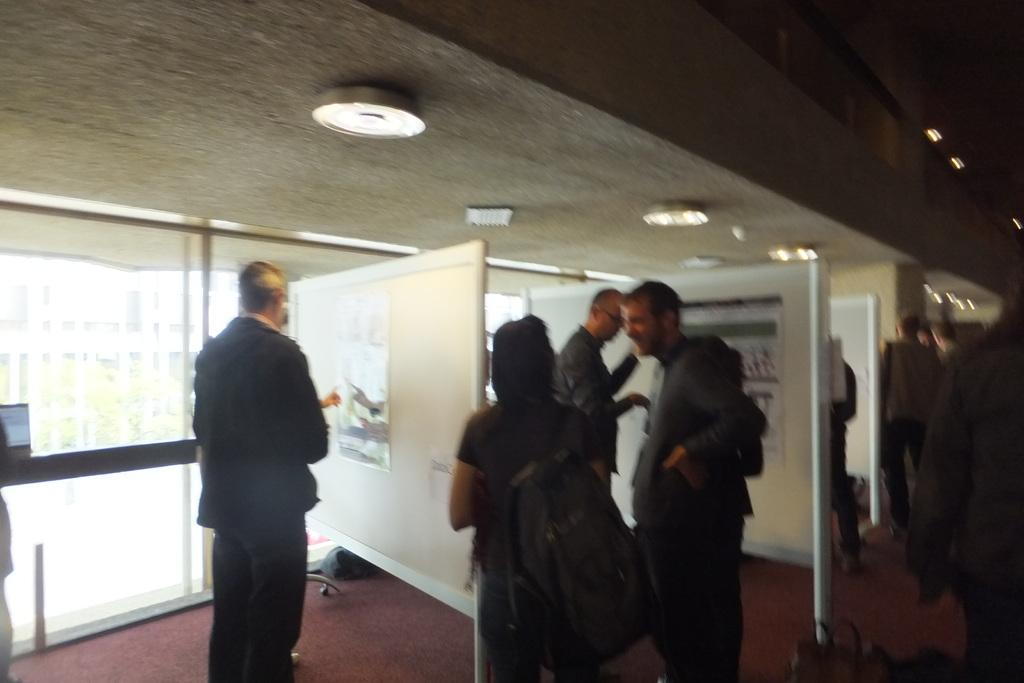What is the main subject of the image? The main subject of the image is a group of people. What are the people in the image doing? The people are standing. What are the people wearing in the image? The people are wearing clothes. Can you describe the position of the person at the bottom of the image? The person at the bottom of the image is standing. What is the person at the bottom of the image holding or wearing? The person at the bottom of the image is wearing a bag. What type of trees can be seen in the background of the image? There are no trees visible in the image; it features a group of people standing. Can you describe the carriage that the people are riding in the image? There is no carriage present in the image; the people are standing. 